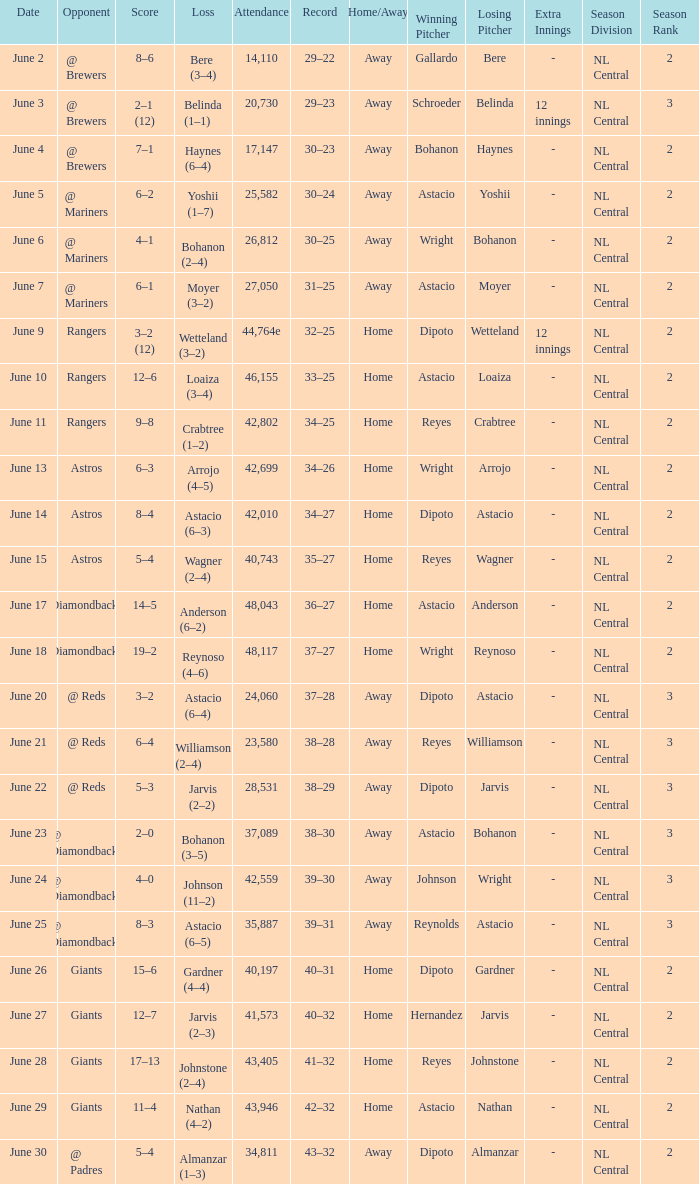What's the record when the attendance was 28,531? 38–29. 